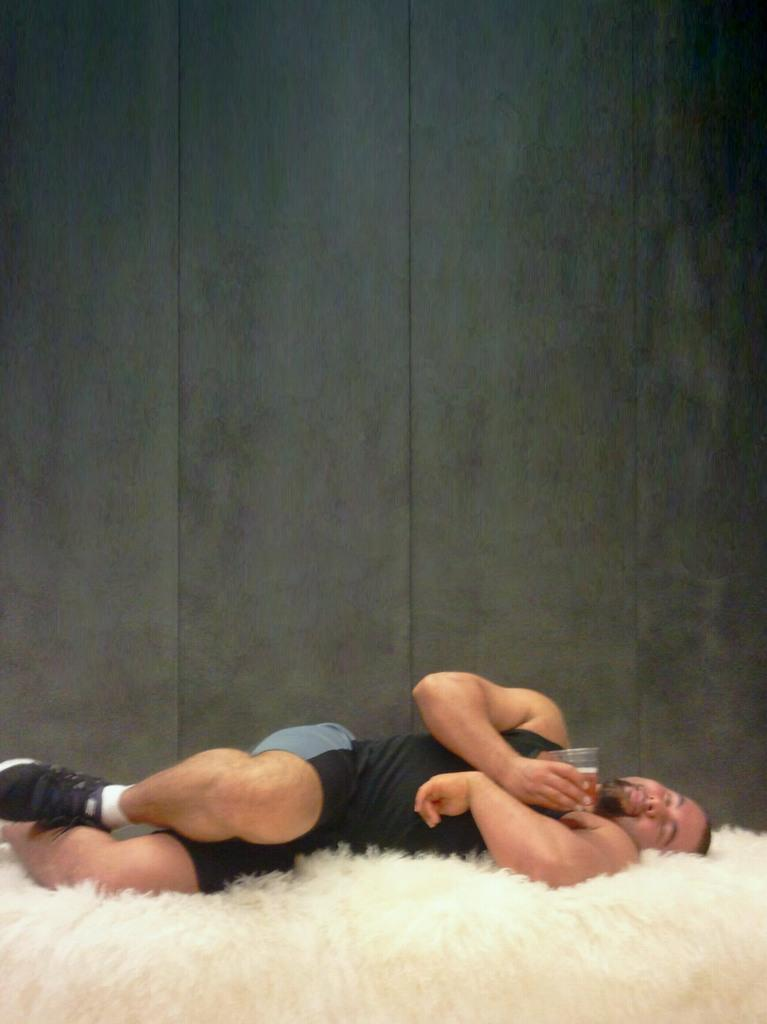Who is present in the image? There is a man in the image. What is the man doing in the image? The man is sleeping on a bed. What is the man holding in his hand? The man is holding a glass in his hand. What can be seen behind the man? There is a wall behind the man. What type of material is visible at the bottom of the image? There is fur at the bottom of the image. Where is the crook hiding in the image? There is no crook present in the image. Can you see any deer in the image? There are no deer present in the image. 